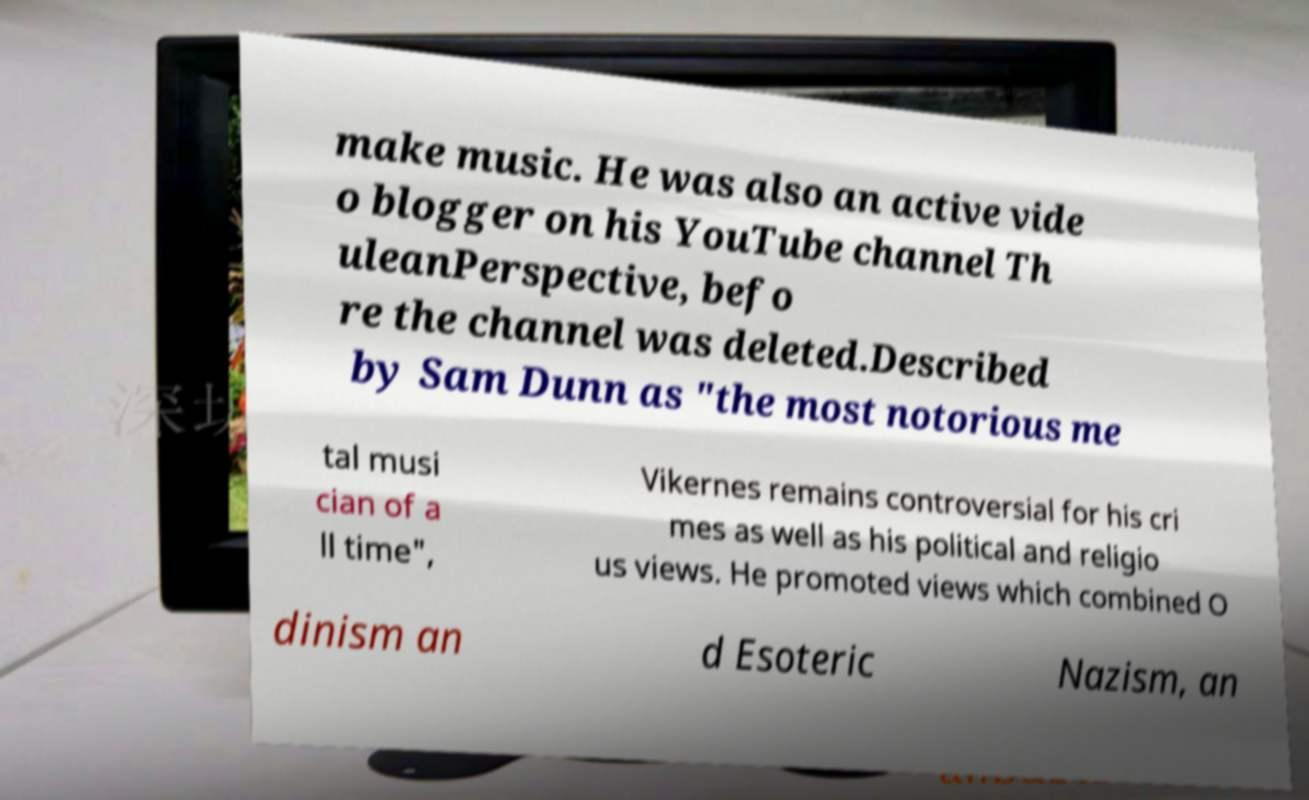What messages or text are displayed in this image? I need them in a readable, typed format. make music. He was also an active vide o blogger on his YouTube channel Th uleanPerspective, befo re the channel was deleted.Described by Sam Dunn as "the most notorious me tal musi cian of a ll time", Vikernes remains controversial for his cri mes as well as his political and religio us views. He promoted views which combined O dinism an d Esoteric Nazism, an 